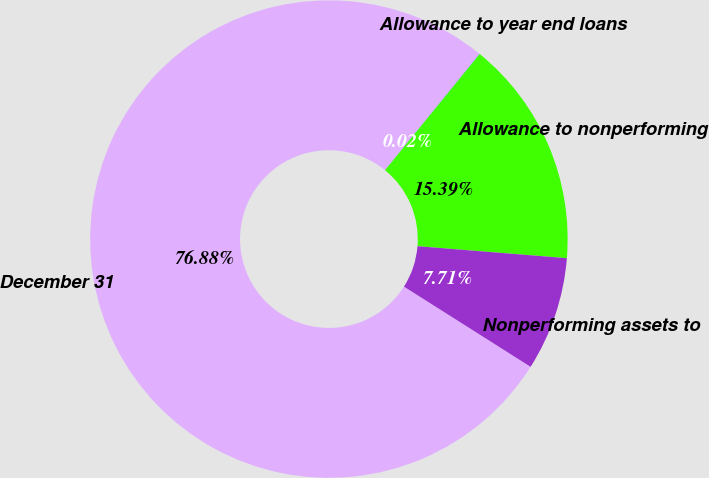Convert chart to OTSL. <chart><loc_0><loc_0><loc_500><loc_500><pie_chart><fcel>December 31<fcel>Allowance to year end loans<fcel>Allowance to nonperforming<fcel>Nonperforming assets to<nl><fcel>76.88%<fcel>0.02%<fcel>15.39%<fcel>7.71%<nl></chart> 